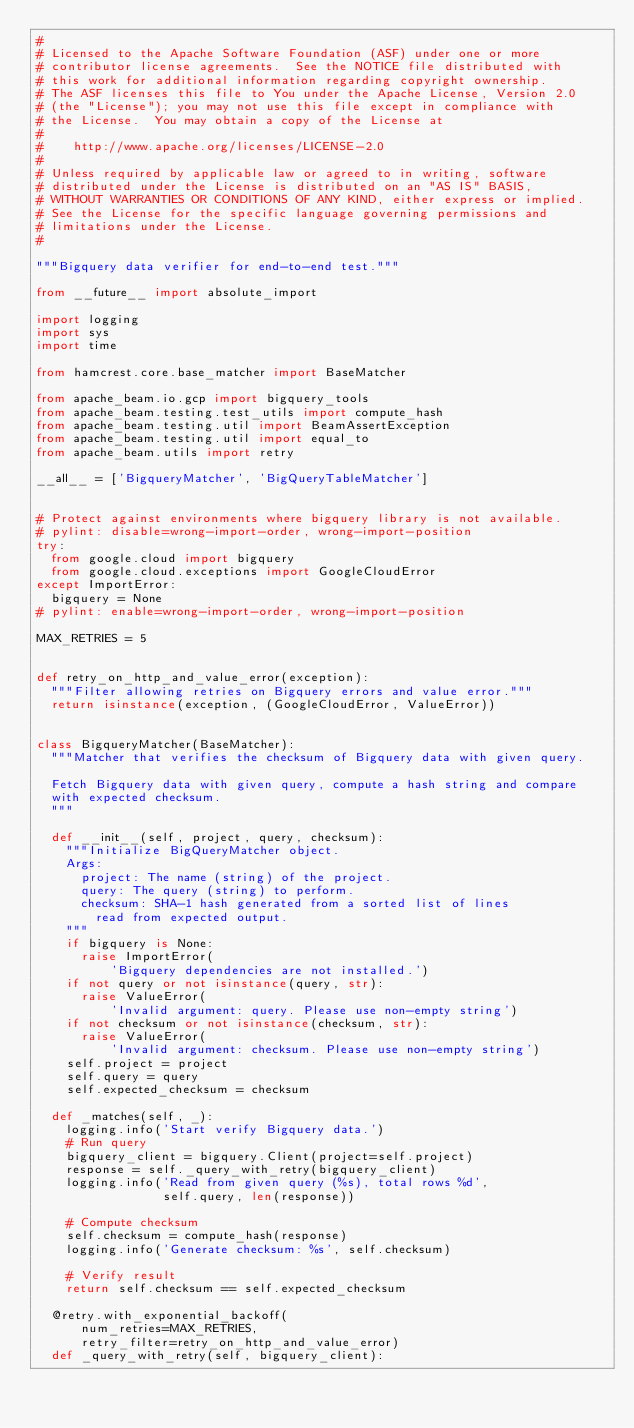Convert code to text. <code><loc_0><loc_0><loc_500><loc_500><_Python_>#
# Licensed to the Apache Software Foundation (ASF) under one or more
# contributor license agreements.  See the NOTICE file distributed with
# this work for additional information regarding copyright ownership.
# The ASF licenses this file to You under the Apache License, Version 2.0
# (the "License"); you may not use this file except in compliance with
# the License.  You may obtain a copy of the License at
#
#    http://www.apache.org/licenses/LICENSE-2.0
#
# Unless required by applicable law or agreed to in writing, software
# distributed under the License is distributed on an "AS IS" BASIS,
# WITHOUT WARRANTIES OR CONDITIONS OF ANY KIND, either express or implied.
# See the License for the specific language governing permissions and
# limitations under the License.
#

"""Bigquery data verifier for end-to-end test."""

from __future__ import absolute_import

import logging
import sys
import time

from hamcrest.core.base_matcher import BaseMatcher

from apache_beam.io.gcp import bigquery_tools
from apache_beam.testing.test_utils import compute_hash
from apache_beam.testing.util import BeamAssertException
from apache_beam.testing.util import equal_to
from apache_beam.utils import retry

__all__ = ['BigqueryMatcher', 'BigQueryTableMatcher']


# Protect against environments where bigquery library is not available.
# pylint: disable=wrong-import-order, wrong-import-position
try:
  from google.cloud import bigquery
  from google.cloud.exceptions import GoogleCloudError
except ImportError:
  bigquery = None
# pylint: enable=wrong-import-order, wrong-import-position

MAX_RETRIES = 5


def retry_on_http_and_value_error(exception):
  """Filter allowing retries on Bigquery errors and value error."""
  return isinstance(exception, (GoogleCloudError, ValueError))


class BigqueryMatcher(BaseMatcher):
  """Matcher that verifies the checksum of Bigquery data with given query.

  Fetch Bigquery data with given query, compute a hash string and compare
  with expected checksum.
  """

  def __init__(self, project, query, checksum):
    """Initialize BigQueryMatcher object.
    Args:
      project: The name (string) of the project.
      query: The query (string) to perform.
      checksum: SHA-1 hash generated from a sorted list of lines
        read from expected output.
    """
    if bigquery is None:
      raise ImportError(
          'Bigquery dependencies are not installed.')
    if not query or not isinstance(query, str):
      raise ValueError(
          'Invalid argument: query. Please use non-empty string')
    if not checksum or not isinstance(checksum, str):
      raise ValueError(
          'Invalid argument: checksum. Please use non-empty string')
    self.project = project
    self.query = query
    self.expected_checksum = checksum

  def _matches(self, _):
    logging.info('Start verify Bigquery data.')
    # Run query
    bigquery_client = bigquery.Client(project=self.project)
    response = self._query_with_retry(bigquery_client)
    logging.info('Read from given query (%s), total rows %d',
                 self.query, len(response))

    # Compute checksum
    self.checksum = compute_hash(response)
    logging.info('Generate checksum: %s', self.checksum)

    # Verify result
    return self.checksum == self.expected_checksum

  @retry.with_exponential_backoff(
      num_retries=MAX_RETRIES,
      retry_filter=retry_on_http_and_value_error)
  def _query_with_retry(self, bigquery_client):</code> 